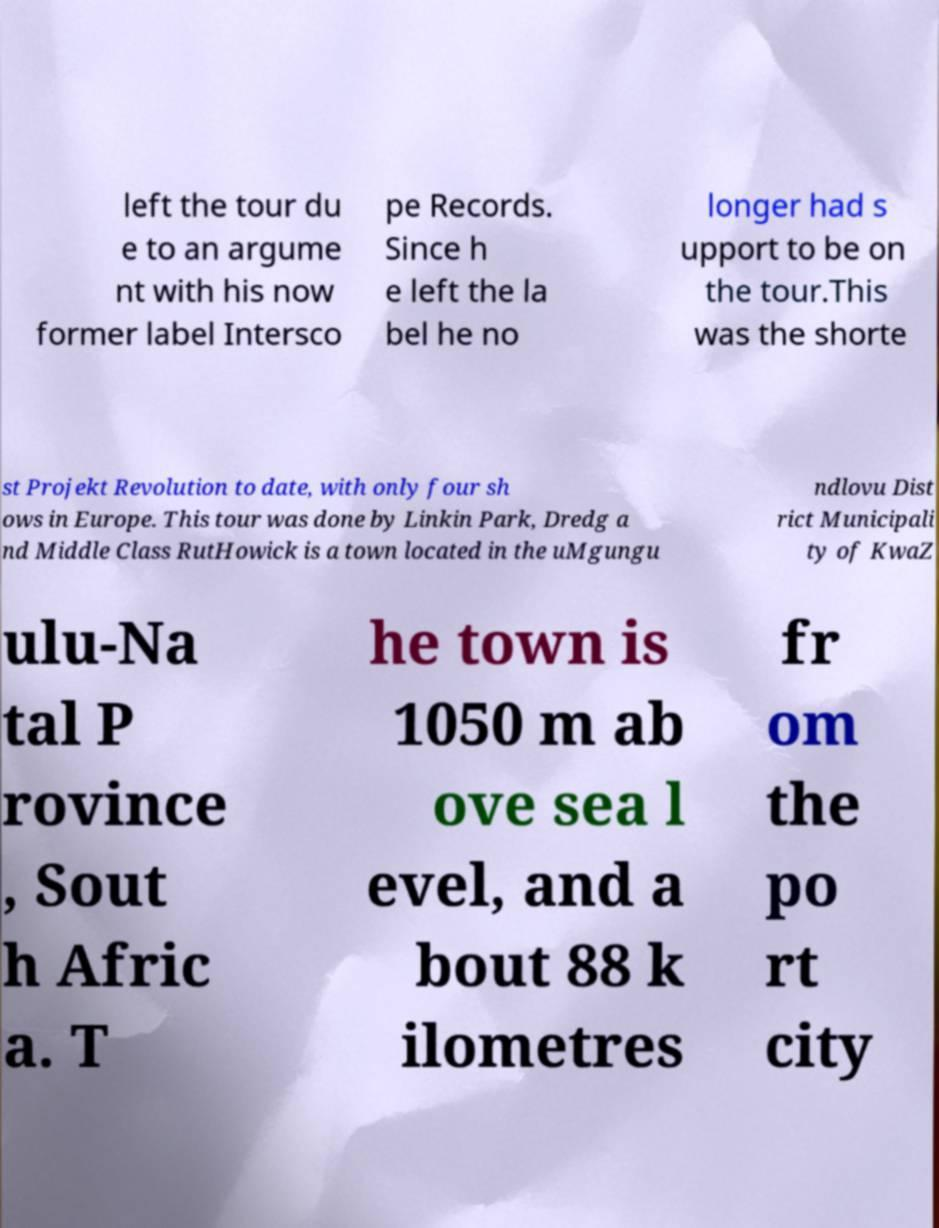For documentation purposes, I need the text within this image transcribed. Could you provide that? left the tour du e to an argume nt with his now former label Intersco pe Records. Since h e left the la bel he no longer had s upport to be on the tour.This was the shorte st Projekt Revolution to date, with only four sh ows in Europe. This tour was done by Linkin Park, Dredg a nd Middle Class RutHowick is a town located in the uMgungu ndlovu Dist rict Municipali ty of KwaZ ulu-Na tal P rovince , Sout h Afric a. T he town is 1050 m ab ove sea l evel, and a bout 88 k ilometres fr om the po rt city 